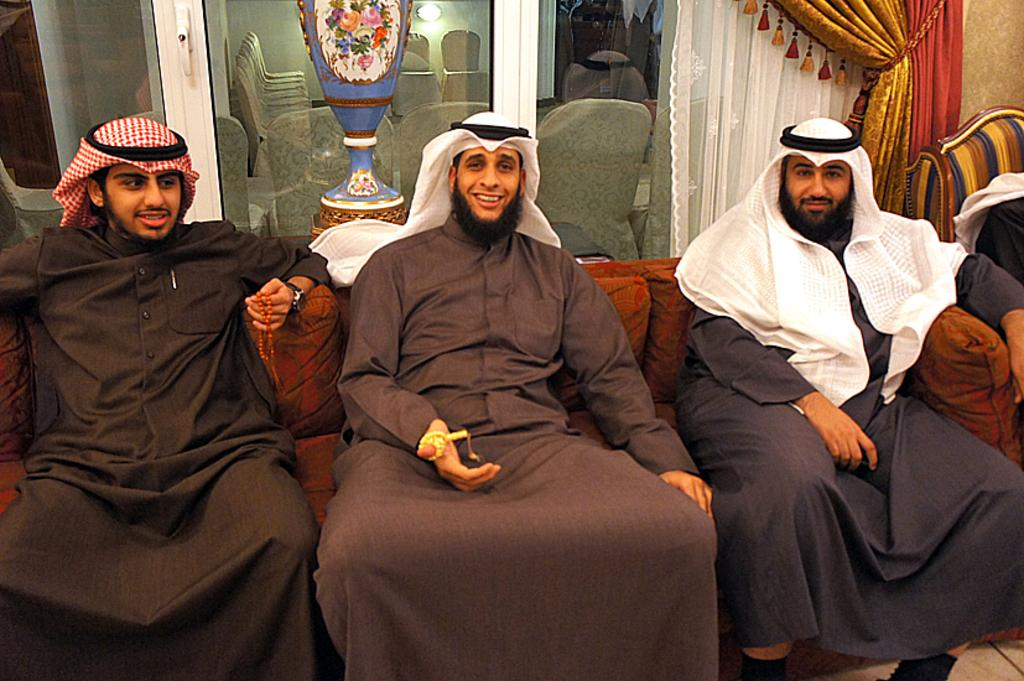How many people are in the image? There are three persons in the image. What are the persons doing in the image? The persons are seated on chairs and smiling. What can be seen in the background of the image? There is a glass door in the background. Are there any chairs visible behind the glass door? Yes, there are chairs behind the glass door. What type of grain is being harvested by the persons in the image? There is no grain or harvesting activity present in the image. How many ears are visible on the persons in the image? The persons in the image are not depicted with ears, as they are not actual people but rather a representation, such as a drawing or painting. 